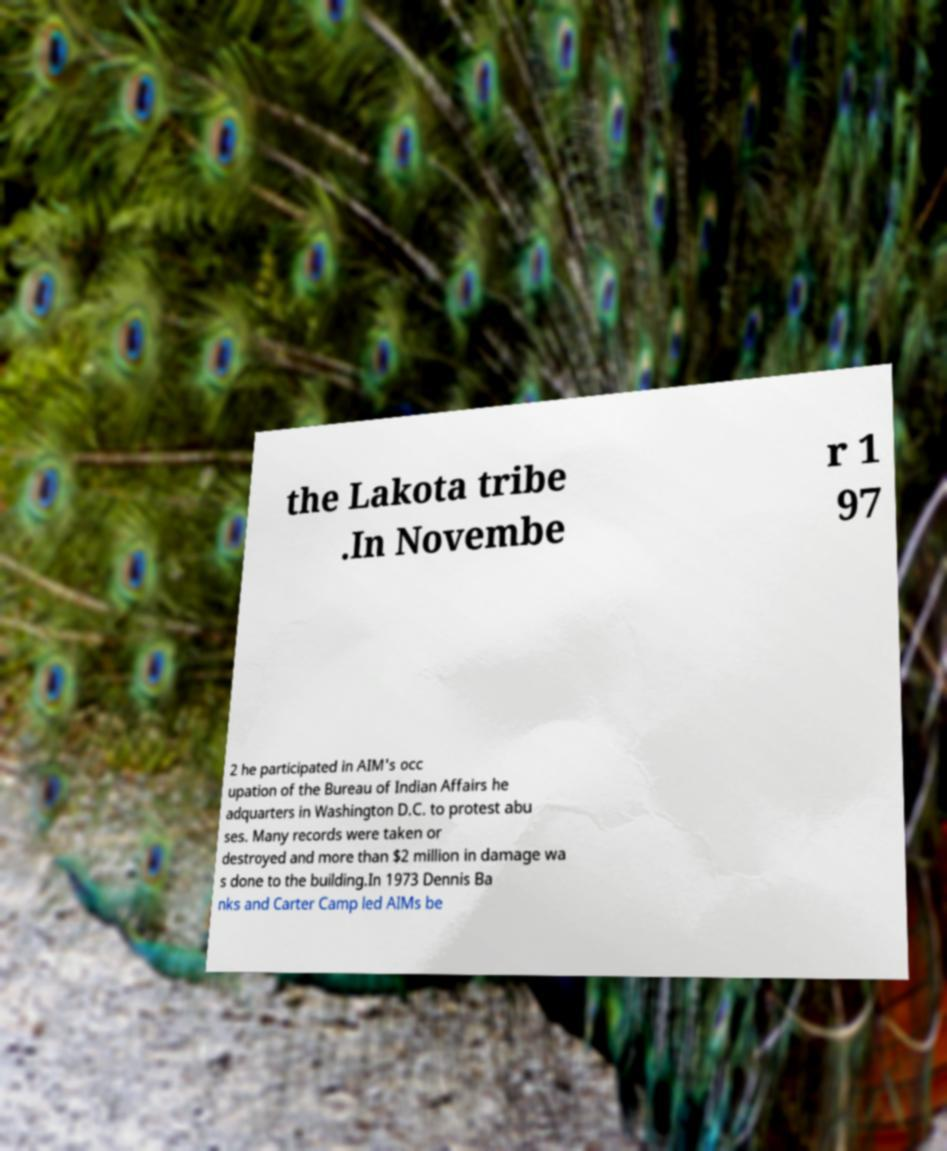I need the written content from this picture converted into text. Can you do that? the Lakota tribe .In Novembe r 1 97 2 he participated in AIM's occ upation of the Bureau of Indian Affairs he adquarters in Washington D.C. to protest abu ses. Many records were taken or destroyed and more than $2 million in damage wa s done to the building.In 1973 Dennis Ba nks and Carter Camp led AIMs be 